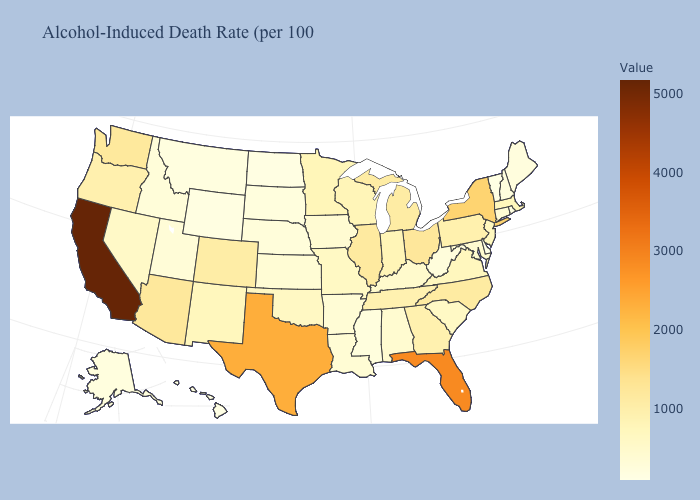Does Mississippi have a lower value than Massachusetts?
Be succinct. Yes. Does Vermont have the lowest value in the Northeast?
Keep it brief. Yes. Does Massachusetts have a higher value than Texas?
Write a very short answer. No. 